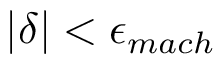Convert formula to latex. <formula><loc_0><loc_0><loc_500><loc_500>| \delta | < \epsilon _ { m a c h }</formula> 